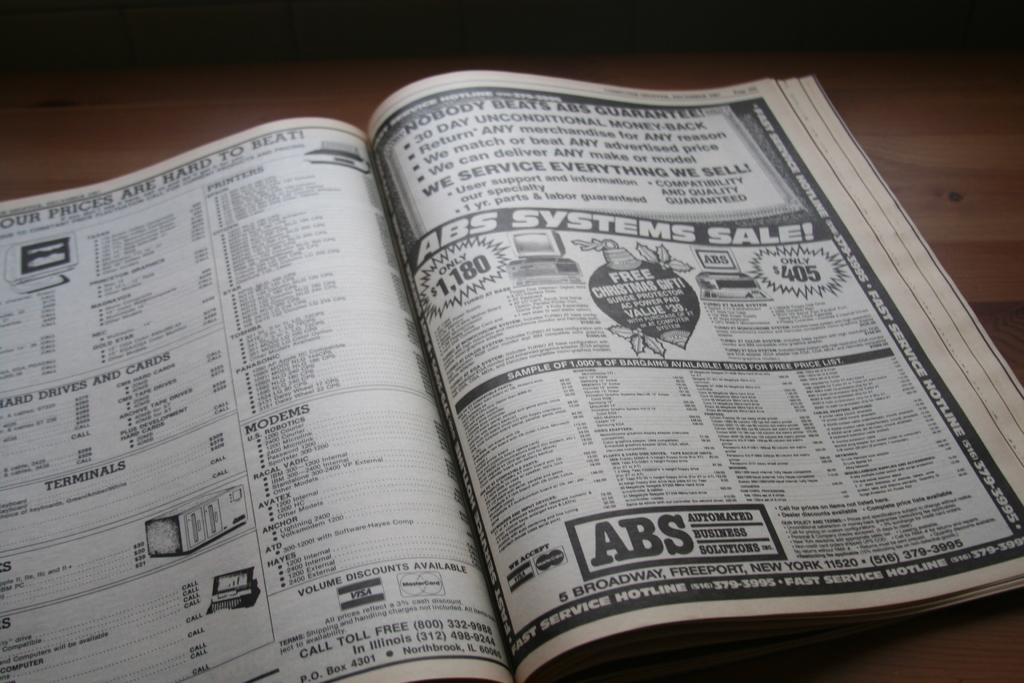<image>
Describe the image concisely. A telephone book is open on a table showing ABS Systems. 